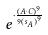<formula> <loc_0><loc_0><loc_500><loc_500>e ^ { \cdot \frac { ( A \cdot C ) ^ { 9 } } { 9 { ( s _ { A } ) } ^ { 9 } } }</formula> 